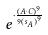<formula> <loc_0><loc_0><loc_500><loc_500>e ^ { \cdot \frac { ( A \cdot C ) ^ { 9 } } { 9 { ( s _ { A } ) } ^ { 9 } } }</formula> 